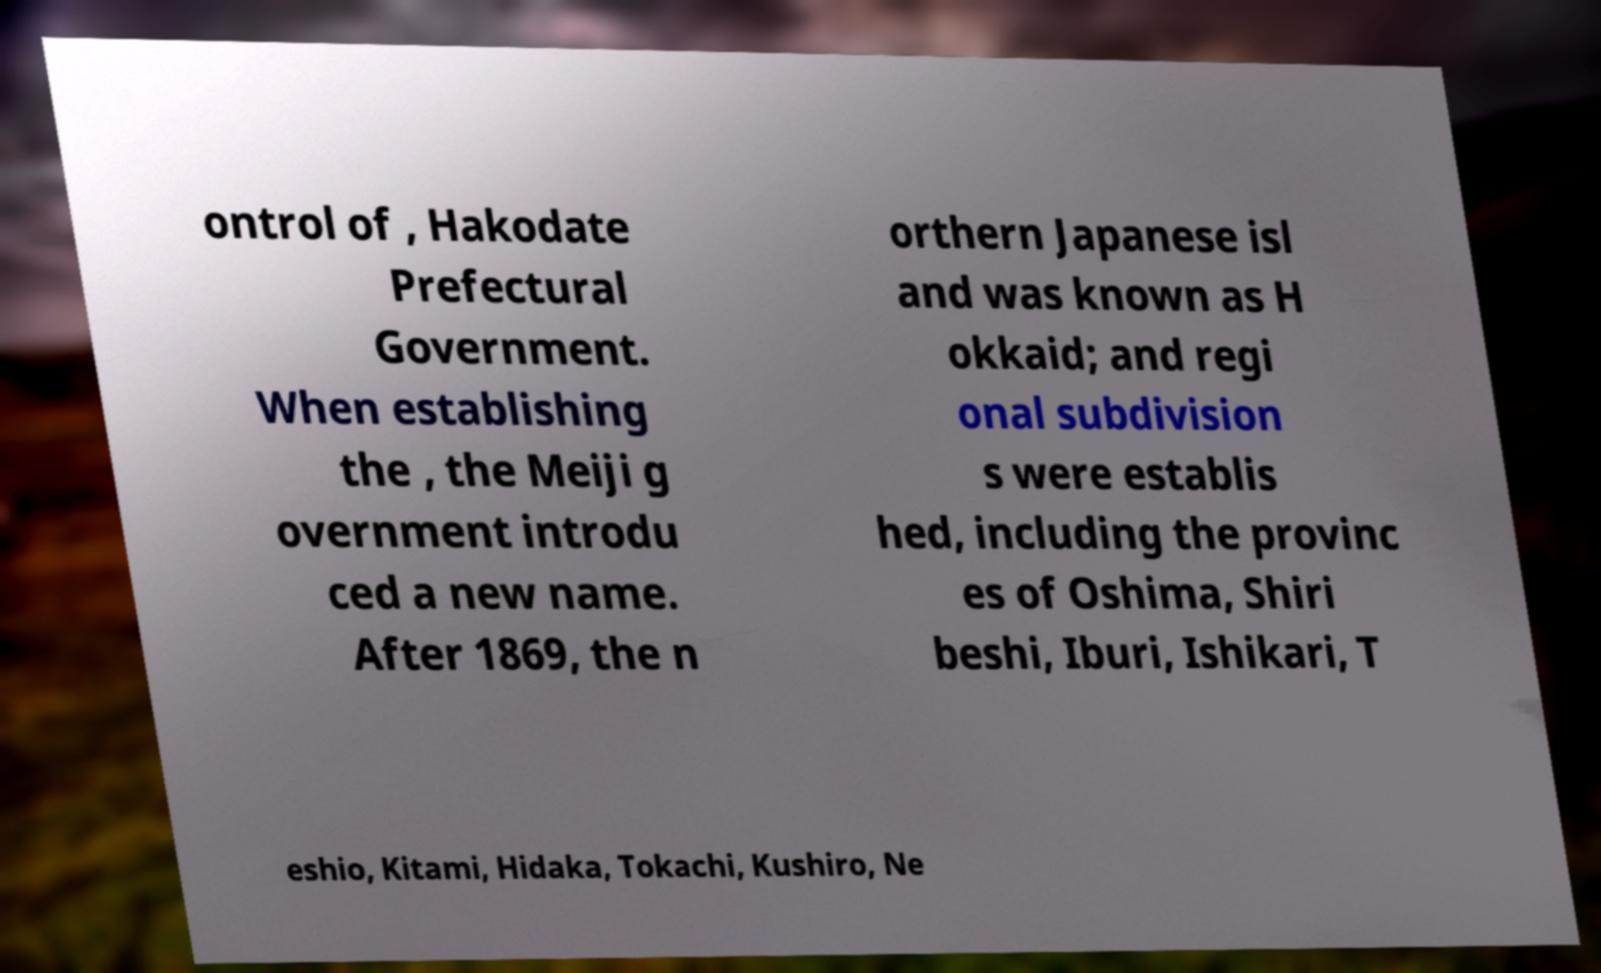Can you accurately transcribe the text from the provided image for me? ontrol of , Hakodate Prefectural Government. When establishing the , the Meiji g overnment introdu ced a new name. After 1869, the n orthern Japanese isl and was known as H okkaid; and regi onal subdivision s were establis hed, including the provinc es of Oshima, Shiri beshi, Iburi, Ishikari, T eshio, Kitami, Hidaka, Tokachi, Kushiro, Ne 